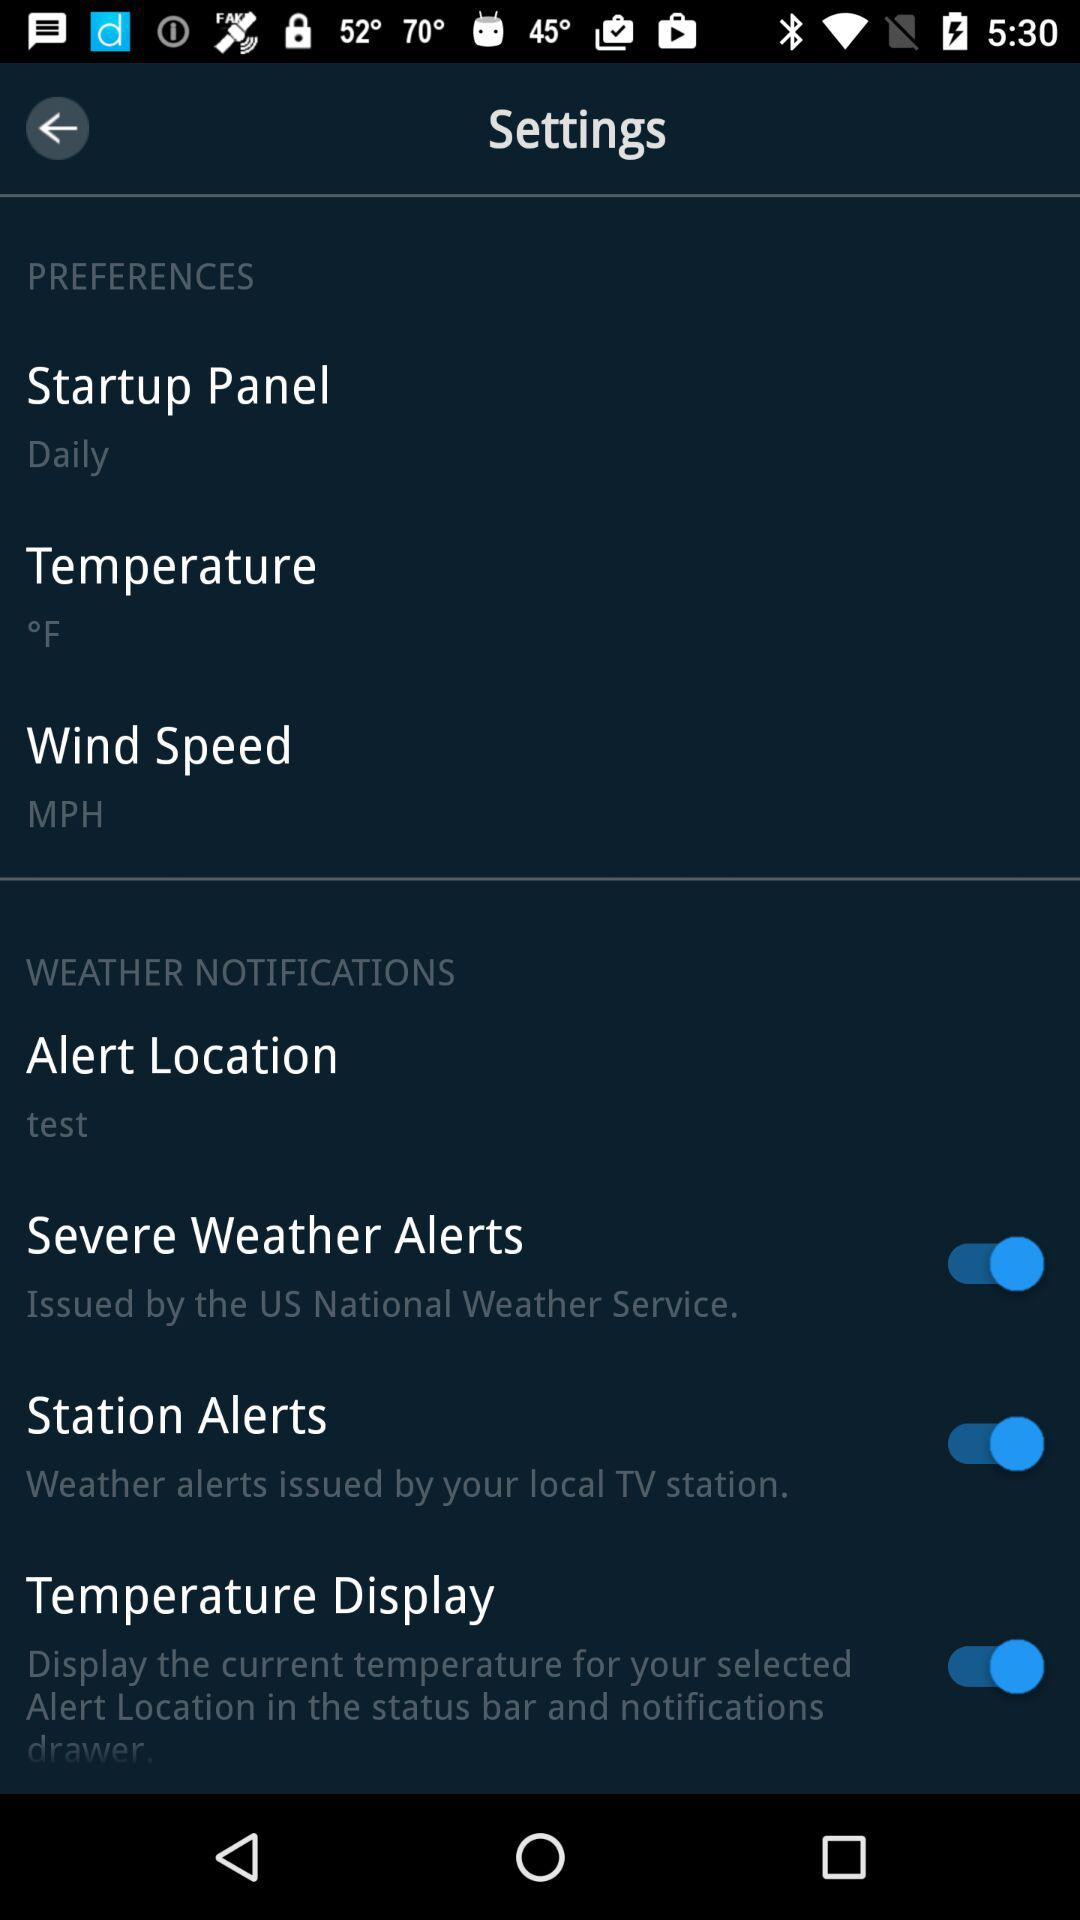What is the mentioned unit of temperature? The mentioned unit of temperature is °F. 